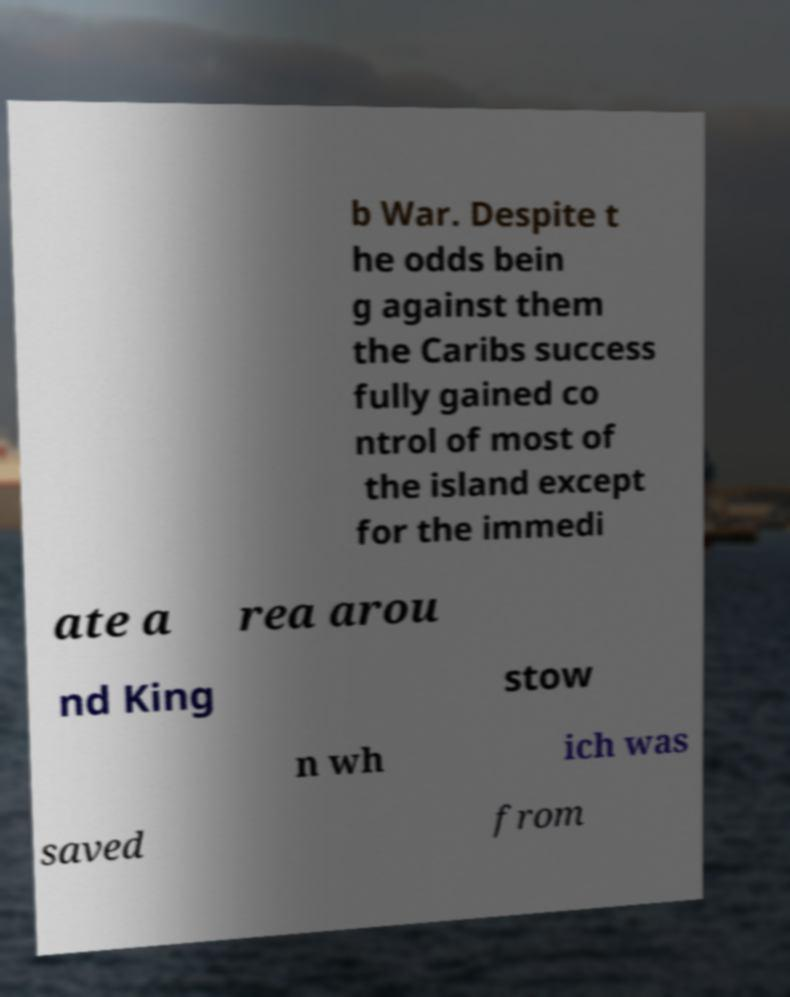What messages or text are displayed in this image? I need them in a readable, typed format. b War. Despite t he odds bein g against them the Caribs success fully gained co ntrol of most of the island except for the immedi ate a rea arou nd King stow n wh ich was saved from 